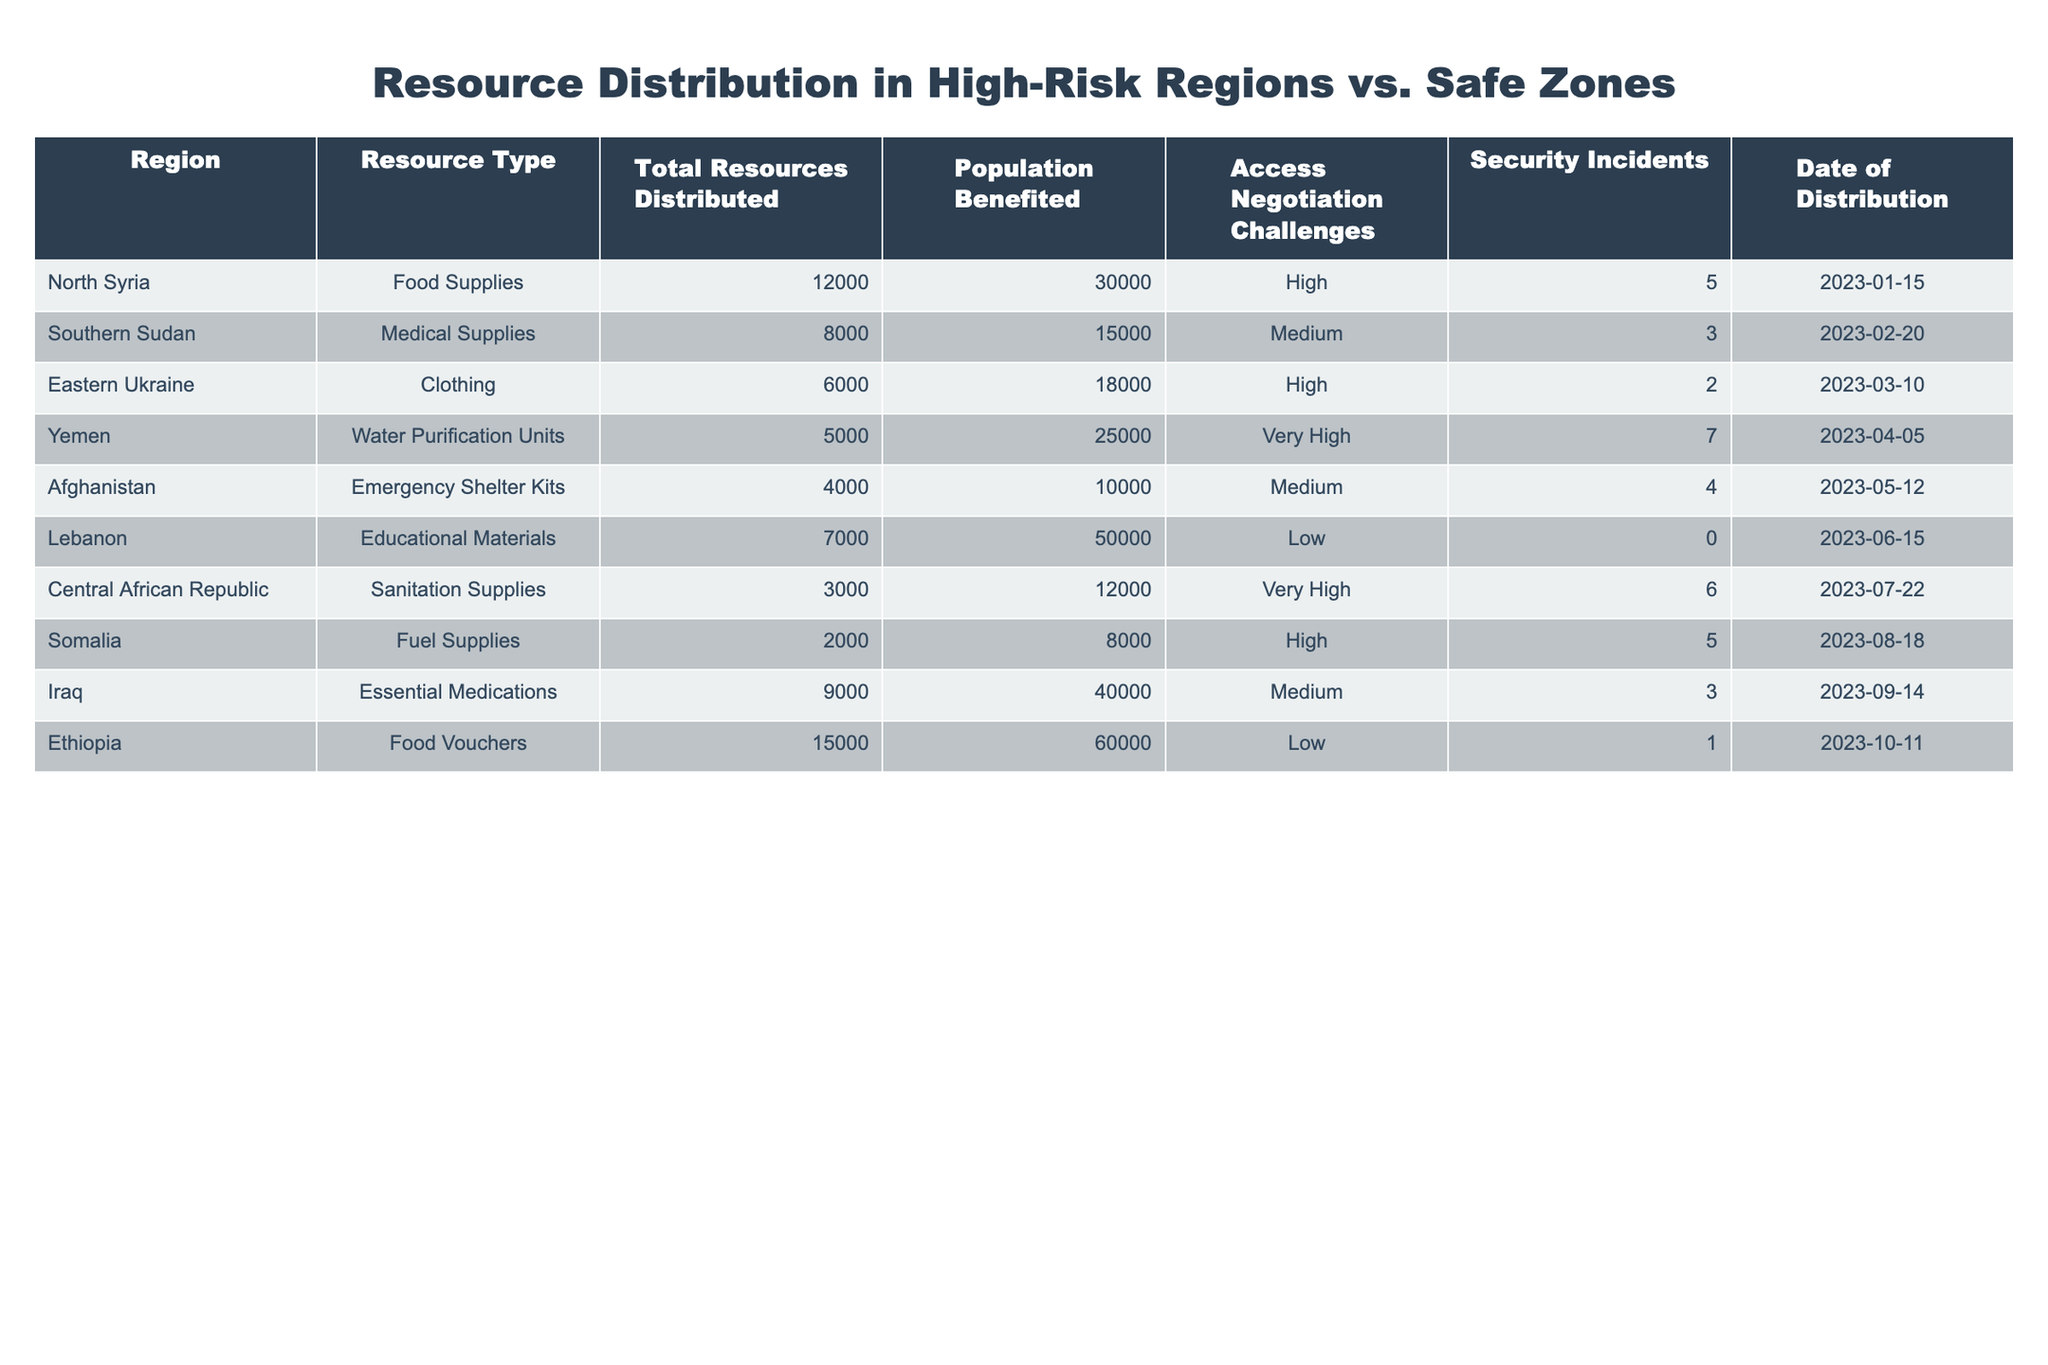What is the total number of food supplies distributed in North Syria? In the table, under the "North Syria" row, the "Total Resources Distributed" for food supplies is listed as 12000.
Answer: 12000 How many people benefited from the medical supplies distributed in Southern Sudan? The table lists the "Population Benefited" for medical supplies in Southern Sudan as 15000.
Answer: 15000 Is there any region where the access negotiation challenges were rated as low? Looking at the "Access Negotiation Challenges" column, "Lebanon" and "Ethiopia" are the regions that are rated as low. Thus, the answer is yes.
Answer: Yes What was the total number of resources distributed in regions with very high access negotiation challenges? The regions with "Very High" access negotiation challenges are Yemen and Central African Republic. The total resources are 5000 (Yemen) + 3000 (Central African Republic) = 8000.
Answer: 8000 Which region had the highest population benefited and what type of resource was distributed? The region with the highest "Population Benefited" is Ethiopia with 60000, which had "Food Vouchers" as the resource distributed.
Answer: Ethiopia, Food Vouchers What is the average number of security incidents across all regions listed in the table? The number of security incidents for each region is: 5, 3, 2, 7, 4, 0, 6, 5, 3, 1. Summing these gives 36 incidents. Dividing by the number of regions (10) gives an average of 3.6.
Answer: 3.6 Which resource type had the least number distributed and what region was it in? The minimum value in the "Total Resources Distributed" column is 2000, which corresponds to the "Fuel Supplies" in Somalia.
Answer: Fuel Supplies, Somalia What is the difference in total resources distributed between high-risk regions and safe zones? High-risk regions with "High" and "Very High" challenges are: North Syria (12000), Eastern Ukraine (6000), Yemen (5000), Somalia (2000), Central African Republic (3000). The total is 30000. Safe zones with "Low" challenges are: Lebanon (7000), Ethiopia (15000), total is 22000. Thus, the difference is 30000 - 22000 = 8000.
Answer: 8000 In how many distributions did the total resources exceed 10000? Checking the "Total Resources Distributed," the regions exceeding 10000 are North Syria (12000), Ethiopia (15000), and Iraq (9000). There are 3 such distributions.
Answer: 3 